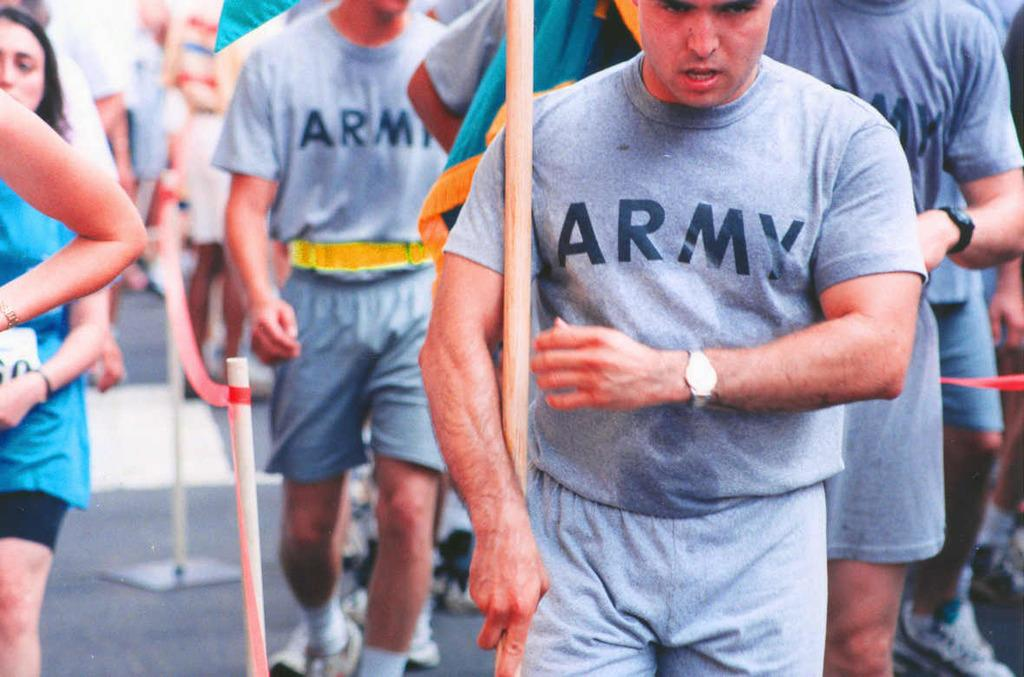<image>
Relay a brief, clear account of the picture shown. Several men in a line wearing gray ARMY t-shirts. 